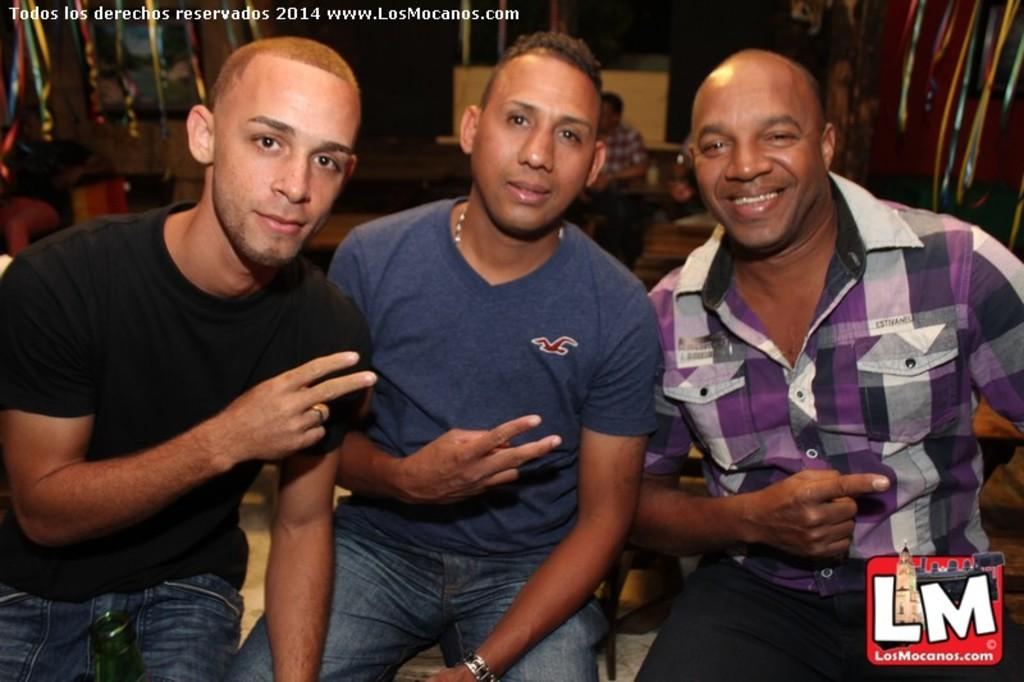What is the main subject in the middle of the image? There is a man sitting in the middle of the image. What is the man wearing in the image? The man is wearing a t-shirt. Who is on the left side of the image? There is a woman on the left side of the image. What is the woman wearing in the image? The woman is wearing a black t-shirt. Who is on the right side of the image? There is a person on the right side of the image. What is the expression of the person on the right side of the image? The person on the right side of the image is smiling. Can you see a receipt in the hands of the person on the right side of the image? There is no receipt present in the image. Is there a monkey whistling in the background of the image? There is no monkey or whistling present in the image. 